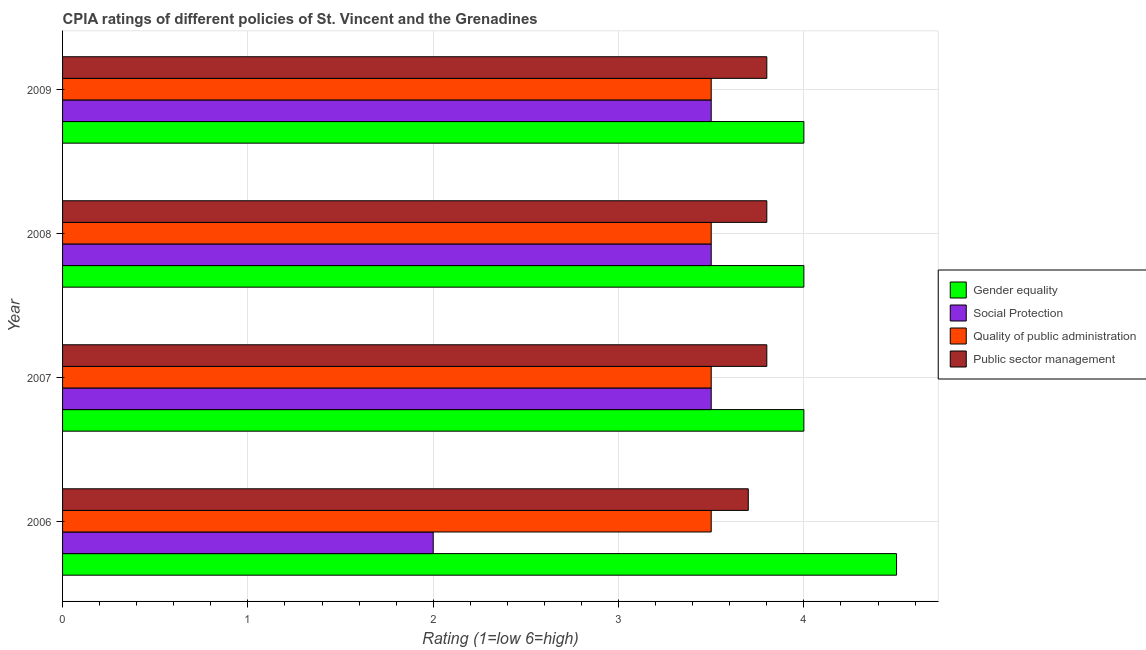How many groups of bars are there?
Ensure brevity in your answer.  4. Are the number of bars on each tick of the Y-axis equal?
Keep it short and to the point. Yes. How many bars are there on the 1st tick from the bottom?
Provide a succinct answer. 4. In how many cases, is the number of bars for a given year not equal to the number of legend labels?
Your answer should be compact. 0. What is the cpia rating of quality of public administration in 2009?
Your answer should be very brief. 3.5. Across all years, what is the maximum cpia rating of gender equality?
Provide a short and direct response. 4.5. Across all years, what is the minimum cpia rating of public sector management?
Provide a succinct answer. 3.7. In which year was the cpia rating of social protection minimum?
Give a very brief answer. 2006. What is the total cpia rating of quality of public administration in the graph?
Keep it short and to the point. 14. What is the difference between the cpia rating of gender equality in 2007 and the cpia rating of public sector management in 2008?
Your answer should be very brief. 0.2. What is the average cpia rating of gender equality per year?
Your answer should be compact. 4.12. What is the ratio of the cpia rating of gender equality in 2006 to that in 2009?
Give a very brief answer. 1.12. Is the sum of the cpia rating of gender equality in 2006 and 2007 greater than the maximum cpia rating of quality of public administration across all years?
Your response must be concise. Yes. Is it the case that in every year, the sum of the cpia rating of social protection and cpia rating of gender equality is greater than the sum of cpia rating of public sector management and cpia rating of quality of public administration?
Your answer should be compact. No. What does the 1st bar from the top in 2006 represents?
Provide a succinct answer. Public sector management. What does the 4th bar from the bottom in 2006 represents?
Your answer should be very brief. Public sector management. Is it the case that in every year, the sum of the cpia rating of gender equality and cpia rating of social protection is greater than the cpia rating of quality of public administration?
Your response must be concise. Yes. How many bars are there?
Your response must be concise. 16. What is the difference between two consecutive major ticks on the X-axis?
Keep it short and to the point. 1. Where does the legend appear in the graph?
Your answer should be compact. Center right. How many legend labels are there?
Your answer should be very brief. 4. What is the title of the graph?
Give a very brief answer. CPIA ratings of different policies of St. Vincent and the Grenadines. What is the label or title of the X-axis?
Offer a very short reply. Rating (1=low 6=high). What is the Rating (1=low 6=high) in Gender equality in 2006?
Your answer should be compact. 4.5. What is the Rating (1=low 6=high) of Gender equality in 2007?
Offer a very short reply. 4. What is the Rating (1=low 6=high) of Gender equality in 2008?
Give a very brief answer. 4. What is the Rating (1=low 6=high) of Social Protection in 2008?
Your answer should be very brief. 3.5. What is the Rating (1=low 6=high) of Quality of public administration in 2009?
Keep it short and to the point. 3.5. What is the Rating (1=low 6=high) in Public sector management in 2009?
Ensure brevity in your answer.  3.8. Across all years, what is the maximum Rating (1=low 6=high) of Gender equality?
Provide a short and direct response. 4.5. Across all years, what is the maximum Rating (1=low 6=high) of Quality of public administration?
Offer a very short reply. 3.5. Across all years, what is the minimum Rating (1=low 6=high) of Gender equality?
Your answer should be compact. 4. Across all years, what is the minimum Rating (1=low 6=high) in Social Protection?
Ensure brevity in your answer.  2. Across all years, what is the minimum Rating (1=low 6=high) of Quality of public administration?
Offer a terse response. 3.5. Across all years, what is the minimum Rating (1=low 6=high) of Public sector management?
Offer a terse response. 3.7. What is the total Rating (1=low 6=high) of Gender equality in the graph?
Your response must be concise. 16.5. What is the total Rating (1=low 6=high) of Social Protection in the graph?
Provide a succinct answer. 12.5. What is the total Rating (1=low 6=high) of Public sector management in the graph?
Make the answer very short. 15.1. What is the difference between the Rating (1=low 6=high) in Gender equality in 2006 and that in 2007?
Provide a short and direct response. 0.5. What is the difference between the Rating (1=low 6=high) in Social Protection in 2006 and that in 2007?
Offer a very short reply. -1.5. What is the difference between the Rating (1=low 6=high) in Social Protection in 2006 and that in 2008?
Provide a short and direct response. -1.5. What is the difference between the Rating (1=low 6=high) of Quality of public administration in 2006 and that in 2008?
Provide a short and direct response. 0. What is the difference between the Rating (1=low 6=high) of Public sector management in 2006 and that in 2008?
Make the answer very short. -0.1. What is the difference between the Rating (1=low 6=high) in Gender equality in 2006 and that in 2009?
Your answer should be very brief. 0.5. What is the difference between the Rating (1=low 6=high) in Quality of public administration in 2006 and that in 2009?
Keep it short and to the point. 0. What is the difference between the Rating (1=low 6=high) of Public sector management in 2006 and that in 2009?
Keep it short and to the point. -0.1. What is the difference between the Rating (1=low 6=high) in Gender equality in 2007 and that in 2008?
Your answer should be compact. 0. What is the difference between the Rating (1=low 6=high) of Social Protection in 2007 and that in 2008?
Make the answer very short. 0. What is the difference between the Rating (1=low 6=high) of Quality of public administration in 2007 and that in 2008?
Your answer should be very brief. 0. What is the difference between the Rating (1=low 6=high) in Public sector management in 2007 and that in 2008?
Make the answer very short. 0. What is the difference between the Rating (1=low 6=high) of Social Protection in 2007 and that in 2009?
Ensure brevity in your answer.  0. What is the difference between the Rating (1=low 6=high) of Gender equality in 2008 and that in 2009?
Provide a short and direct response. 0. What is the difference between the Rating (1=low 6=high) of Gender equality in 2006 and the Rating (1=low 6=high) of Social Protection in 2007?
Your answer should be compact. 1. What is the difference between the Rating (1=low 6=high) of Gender equality in 2006 and the Rating (1=low 6=high) of Quality of public administration in 2007?
Offer a very short reply. 1. What is the difference between the Rating (1=low 6=high) of Social Protection in 2006 and the Rating (1=low 6=high) of Quality of public administration in 2007?
Keep it short and to the point. -1.5. What is the difference between the Rating (1=low 6=high) of Quality of public administration in 2006 and the Rating (1=low 6=high) of Public sector management in 2007?
Keep it short and to the point. -0.3. What is the difference between the Rating (1=low 6=high) in Gender equality in 2006 and the Rating (1=low 6=high) in Social Protection in 2008?
Make the answer very short. 1. What is the difference between the Rating (1=low 6=high) in Gender equality in 2006 and the Rating (1=low 6=high) in Quality of public administration in 2008?
Make the answer very short. 1. What is the difference between the Rating (1=low 6=high) in Gender equality in 2006 and the Rating (1=low 6=high) in Public sector management in 2008?
Give a very brief answer. 0.7. What is the difference between the Rating (1=low 6=high) in Social Protection in 2006 and the Rating (1=low 6=high) in Quality of public administration in 2008?
Your answer should be compact. -1.5. What is the difference between the Rating (1=low 6=high) of Quality of public administration in 2006 and the Rating (1=low 6=high) of Public sector management in 2008?
Give a very brief answer. -0.3. What is the difference between the Rating (1=low 6=high) in Gender equality in 2006 and the Rating (1=low 6=high) in Social Protection in 2009?
Give a very brief answer. 1. What is the difference between the Rating (1=low 6=high) of Gender equality in 2006 and the Rating (1=low 6=high) of Quality of public administration in 2009?
Give a very brief answer. 1. What is the difference between the Rating (1=low 6=high) of Gender equality in 2006 and the Rating (1=low 6=high) of Public sector management in 2009?
Your answer should be very brief. 0.7. What is the difference between the Rating (1=low 6=high) of Social Protection in 2006 and the Rating (1=low 6=high) of Quality of public administration in 2009?
Your answer should be compact. -1.5. What is the difference between the Rating (1=low 6=high) in Social Protection in 2006 and the Rating (1=low 6=high) in Public sector management in 2009?
Your answer should be compact. -1.8. What is the difference between the Rating (1=low 6=high) in Gender equality in 2007 and the Rating (1=low 6=high) in Quality of public administration in 2008?
Offer a terse response. 0.5. What is the difference between the Rating (1=low 6=high) of Gender equality in 2007 and the Rating (1=low 6=high) of Public sector management in 2008?
Ensure brevity in your answer.  0.2. What is the difference between the Rating (1=low 6=high) in Social Protection in 2007 and the Rating (1=low 6=high) in Quality of public administration in 2008?
Give a very brief answer. 0. What is the difference between the Rating (1=low 6=high) in Social Protection in 2007 and the Rating (1=low 6=high) in Public sector management in 2008?
Your response must be concise. -0.3. What is the difference between the Rating (1=low 6=high) in Gender equality in 2008 and the Rating (1=low 6=high) in Quality of public administration in 2009?
Keep it short and to the point. 0.5. What is the difference between the Rating (1=low 6=high) of Quality of public administration in 2008 and the Rating (1=low 6=high) of Public sector management in 2009?
Keep it short and to the point. -0.3. What is the average Rating (1=low 6=high) of Gender equality per year?
Make the answer very short. 4.12. What is the average Rating (1=low 6=high) in Social Protection per year?
Give a very brief answer. 3.12. What is the average Rating (1=low 6=high) in Quality of public administration per year?
Provide a short and direct response. 3.5. What is the average Rating (1=low 6=high) in Public sector management per year?
Provide a succinct answer. 3.77. In the year 2006, what is the difference between the Rating (1=low 6=high) in Gender equality and Rating (1=low 6=high) in Social Protection?
Your response must be concise. 2.5. In the year 2006, what is the difference between the Rating (1=low 6=high) of Gender equality and Rating (1=low 6=high) of Public sector management?
Give a very brief answer. 0.8. In the year 2006, what is the difference between the Rating (1=low 6=high) of Social Protection and Rating (1=low 6=high) of Quality of public administration?
Offer a very short reply. -1.5. In the year 2006, what is the difference between the Rating (1=low 6=high) in Social Protection and Rating (1=low 6=high) in Public sector management?
Provide a succinct answer. -1.7. In the year 2006, what is the difference between the Rating (1=low 6=high) of Quality of public administration and Rating (1=low 6=high) of Public sector management?
Provide a short and direct response. -0.2. In the year 2007, what is the difference between the Rating (1=low 6=high) in Gender equality and Rating (1=low 6=high) in Quality of public administration?
Your answer should be very brief. 0.5. In the year 2007, what is the difference between the Rating (1=low 6=high) in Social Protection and Rating (1=low 6=high) in Quality of public administration?
Your answer should be compact. 0. In the year 2008, what is the difference between the Rating (1=low 6=high) in Gender equality and Rating (1=low 6=high) in Social Protection?
Offer a very short reply. 0.5. In the year 2008, what is the difference between the Rating (1=low 6=high) in Gender equality and Rating (1=low 6=high) in Quality of public administration?
Offer a terse response. 0.5. In the year 2009, what is the difference between the Rating (1=low 6=high) in Gender equality and Rating (1=low 6=high) in Social Protection?
Ensure brevity in your answer.  0.5. In the year 2009, what is the difference between the Rating (1=low 6=high) of Social Protection and Rating (1=low 6=high) of Public sector management?
Provide a succinct answer. -0.3. What is the ratio of the Rating (1=low 6=high) in Social Protection in 2006 to that in 2007?
Ensure brevity in your answer.  0.57. What is the ratio of the Rating (1=low 6=high) in Public sector management in 2006 to that in 2007?
Make the answer very short. 0.97. What is the ratio of the Rating (1=low 6=high) of Quality of public administration in 2006 to that in 2008?
Give a very brief answer. 1. What is the ratio of the Rating (1=low 6=high) of Public sector management in 2006 to that in 2008?
Your answer should be very brief. 0.97. What is the ratio of the Rating (1=low 6=high) in Gender equality in 2006 to that in 2009?
Your answer should be very brief. 1.12. What is the ratio of the Rating (1=low 6=high) of Social Protection in 2006 to that in 2009?
Offer a very short reply. 0.57. What is the ratio of the Rating (1=low 6=high) of Public sector management in 2006 to that in 2009?
Provide a short and direct response. 0.97. What is the ratio of the Rating (1=low 6=high) in Quality of public administration in 2007 to that in 2008?
Provide a short and direct response. 1. What is the ratio of the Rating (1=low 6=high) of Gender equality in 2007 to that in 2009?
Make the answer very short. 1. What is the ratio of the Rating (1=low 6=high) of Social Protection in 2007 to that in 2009?
Provide a succinct answer. 1. What is the ratio of the Rating (1=low 6=high) in Gender equality in 2008 to that in 2009?
Ensure brevity in your answer.  1. What is the ratio of the Rating (1=low 6=high) in Quality of public administration in 2008 to that in 2009?
Ensure brevity in your answer.  1. What is the ratio of the Rating (1=low 6=high) in Public sector management in 2008 to that in 2009?
Your answer should be very brief. 1. What is the difference between the highest and the second highest Rating (1=low 6=high) of Gender equality?
Your response must be concise. 0.5. What is the difference between the highest and the second highest Rating (1=low 6=high) in Social Protection?
Provide a succinct answer. 0. What is the difference between the highest and the second highest Rating (1=low 6=high) of Quality of public administration?
Make the answer very short. 0. What is the difference between the highest and the second highest Rating (1=low 6=high) of Public sector management?
Your answer should be compact. 0. What is the difference between the highest and the lowest Rating (1=low 6=high) of Gender equality?
Ensure brevity in your answer.  0.5. What is the difference between the highest and the lowest Rating (1=low 6=high) of Social Protection?
Ensure brevity in your answer.  1.5. What is the difference between the highest and the lowest Rating (1=low 6=high) of Quality of public administration?
Give a very brief answer. 0. What is the difference between the highest and the lowest Rating (1=low 6=high) of Public sector management?
Offer a very short reply. 0.1. 